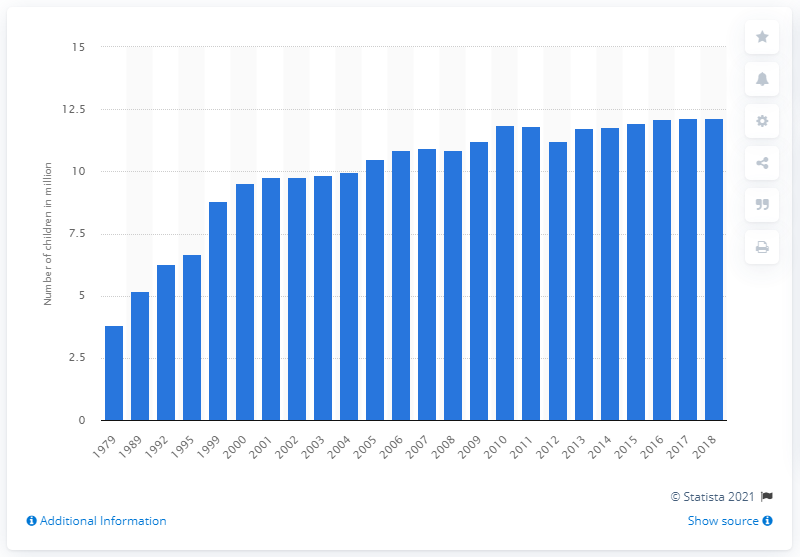Point out several critical features in this image. In 2018, it was reported that 12.13% of children spoke another language at home. In 2018, it was reported that 12.13% of children in the United States spoke another language at home. 